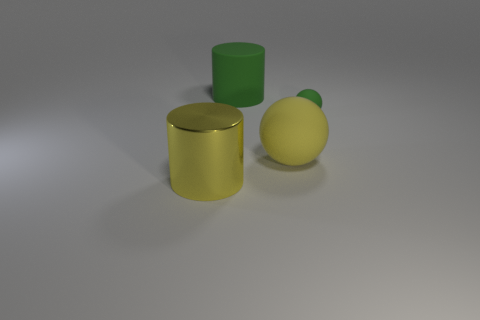Are there any other things that are made of the same material as the large yellow cylinder?
Ensure brevity in your answer.  No. There is a large matte thing that is the same color as the tiny rubber ball; what is its shape?
Your answer should be very brief. Cylinder. There is a cylinder that is the same color as the large sphere; what material is it?
Your response must be concise. Metal. Is there another large green thing that has the same shape as the shiny thing?
Your answer should be compact. Yes. There is a tiny thing behind the yellow metal cylinder; is its shape the same as the big yellow object on the right side of the large green matte cylinder?
Offer a terse response. Yes. Is there a yellow metal thing of the same size as the green rubber cylinder?
Provide a short and direct response. Yes. Is the number of green rubber spheres to the left of the metallic thing the same as the number of green objects right of the tiny green sphere?
Your answer should be very brief. Yes. Are the green thing in front of the matte cylinder and the cylinder that is behind the yellow rubber thing made of the same material?
Your response must be concise. Yes. What is the material of the small green ball?
Keep it short and to the point. Rubber. How many other things are the same color as the large metal thing?
Provide a succinct answer. 1. 